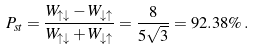<formula> <loc_0><loc_0><loc_500><loc_500>P _ { s t } = \frac { W _ { \uparrow \downarrow } - W _ { \downarrow \uparrow } } { W _ { \uparrow \downarrow } + W _ { \downarrow \uparrow } } = \frac { 8 } { 5 \sqrt { 3 } } = 9 2 . 3 8 \% \, .</formula> 